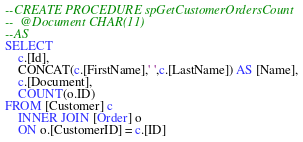Convert code to text. <code><loc_0><loc_0><loc_500><loc_500><_SQL_>--CREATE PROCEDURE spGetCustomerOrdersCount
--	@Document CHAR(11)
--AS
SELECT
    c.[Id],
    CONCAT(c.[FirstName],' ',c.[LastName]) AS [Name],
    c.[Document],
    COUNT(o.ID)
FROM [Customer] c
    INNER JOIN [Order] o
    ON o.[CustomerID] = c.[ID]

</code> 